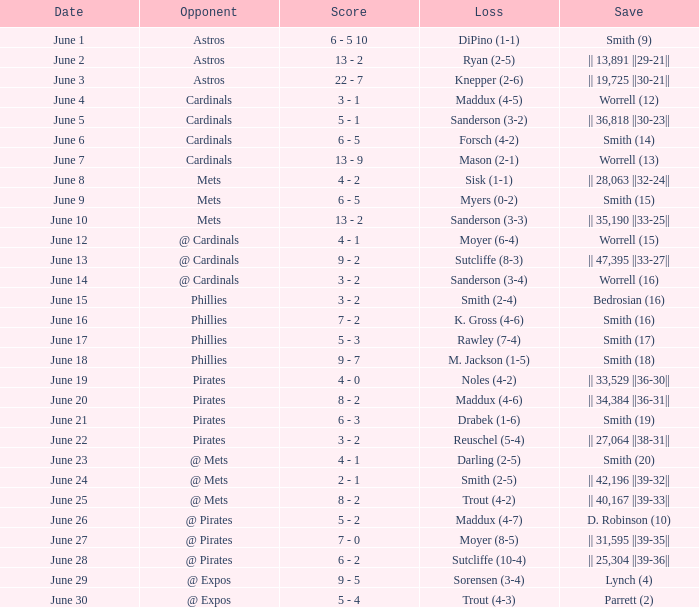Which day witnessed a trout loss (4-2) for the chicago cubs? June 25. 